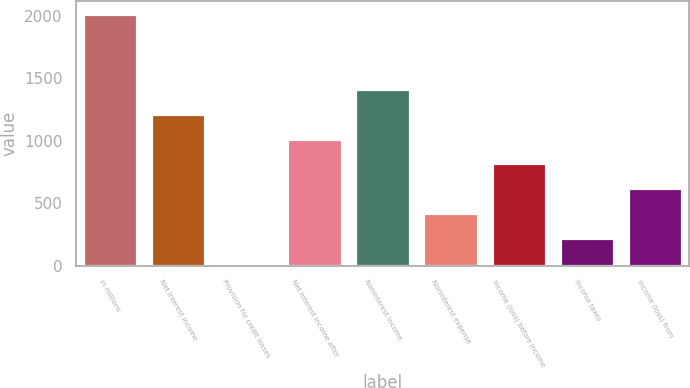<chart> <loc_0><loc_0><loc_500><loc_500><bar_chart><fcel>in millions<fcel>Net interest income<fcel>Provision for credit losses<fcel>Net interest income after<fcel>Noninterest income<fcel>Noninterest expense<fcel>Income (loss) before income<fcel>Income taxes<fcel>Income (loss) from<nl><fcel>2014<fcel>1216.8<fcel>21<fcel>1017.5<fcel>1416.1<fcel>419.6<fcel>818.2<fcel>220.3<fcel>618.9<nl></chart> 